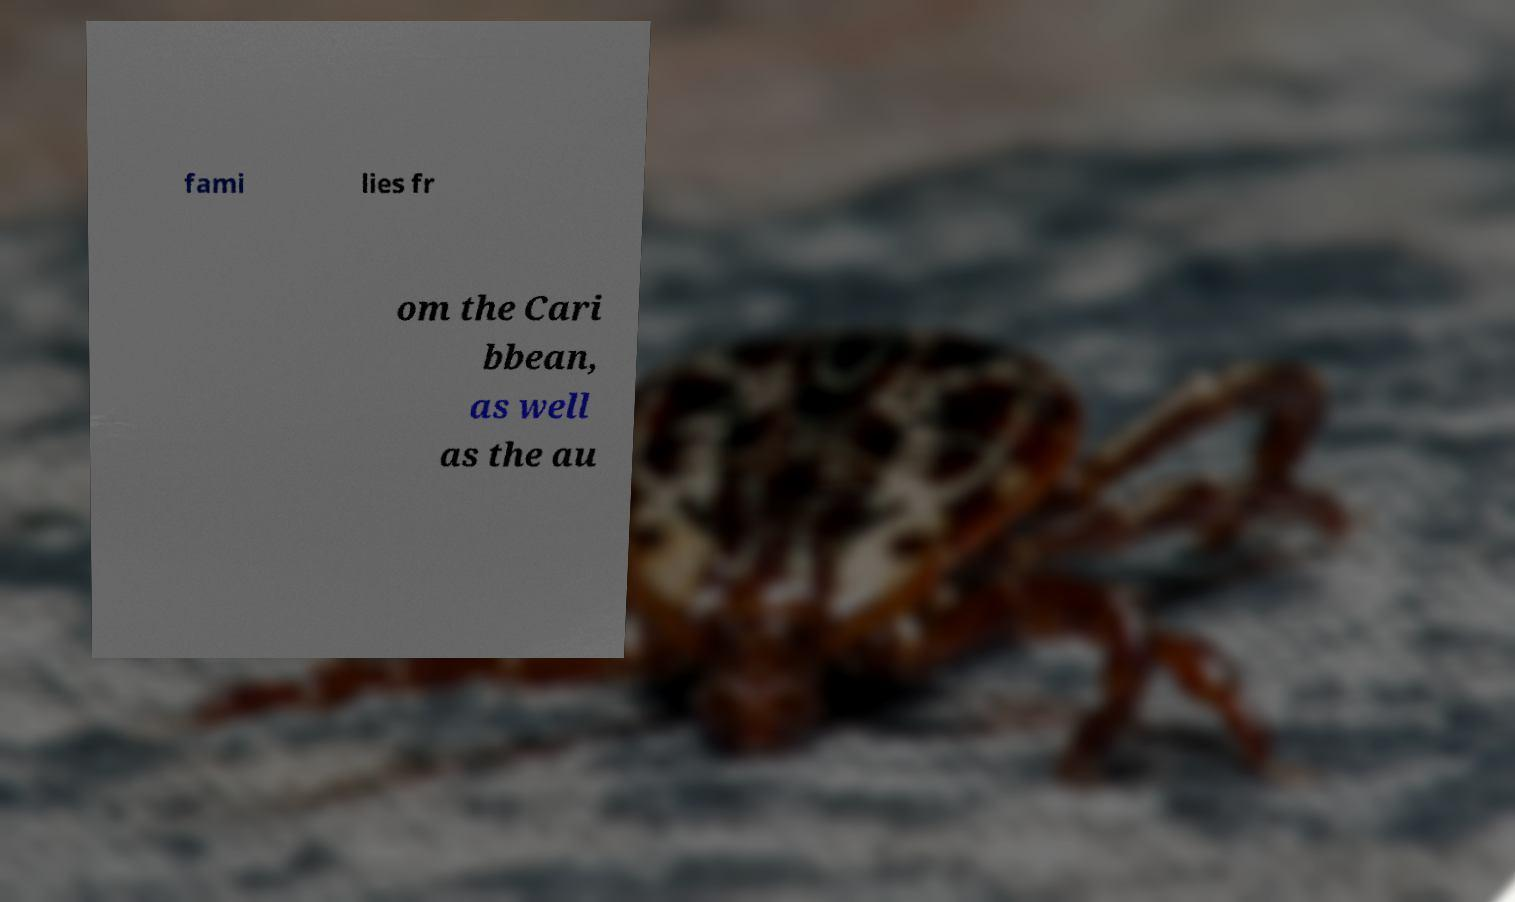Can you read and provide the text displayed in the image?This photo seems to have some interesting text. Can you extract and type it out for me? fami lies fr om the Cari bbean, as well as the au 